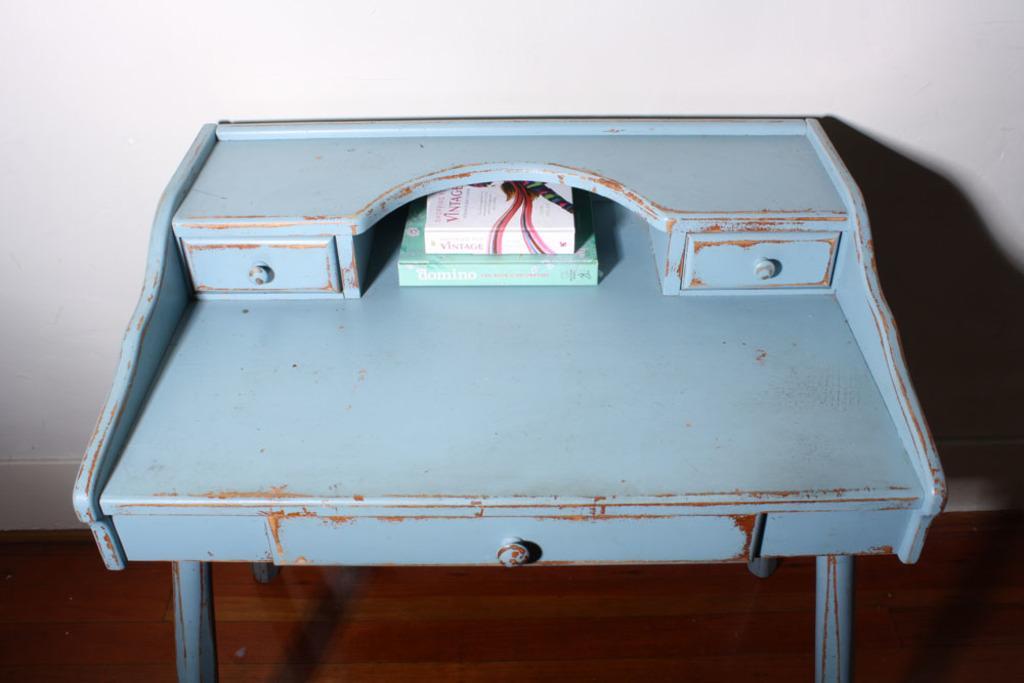Can you describe this image briefly? In the center of this picture we can see the two objects seems to be the books are placed on the top of a blue color table and we can see the text on the cover of the books. In the background we can see the wall. 